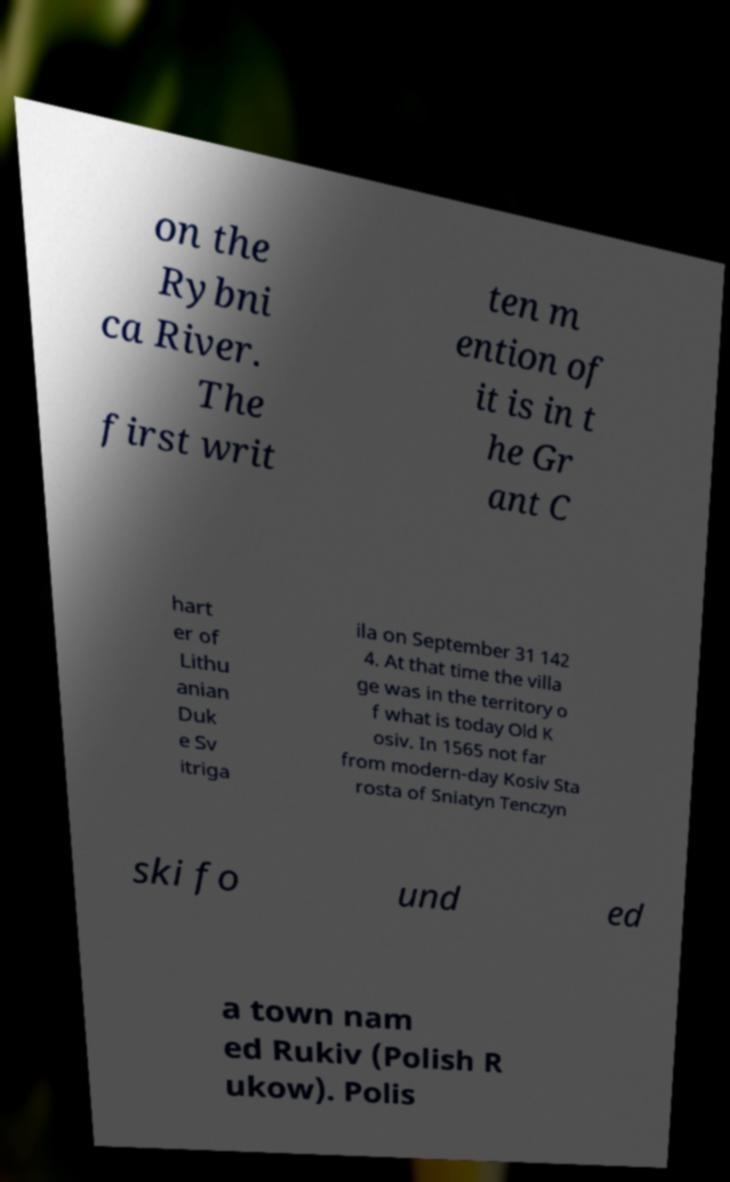Please identify and transcribe the text found in this image. on the Rybni ca River. The first writ ten m ention of it is in t he Gr ant C hart er of Lithu anian Duk e Sv itriga ila on September 31 142 4. At that time the villa ge was in the territory o f what is today Old K osiv. In 1565 not far from modern-day Kosiv Sta rosta of Sniatyn Tenczyn ski fo und ed a town nam ed Rukiv (Polish R ukow). Polis 